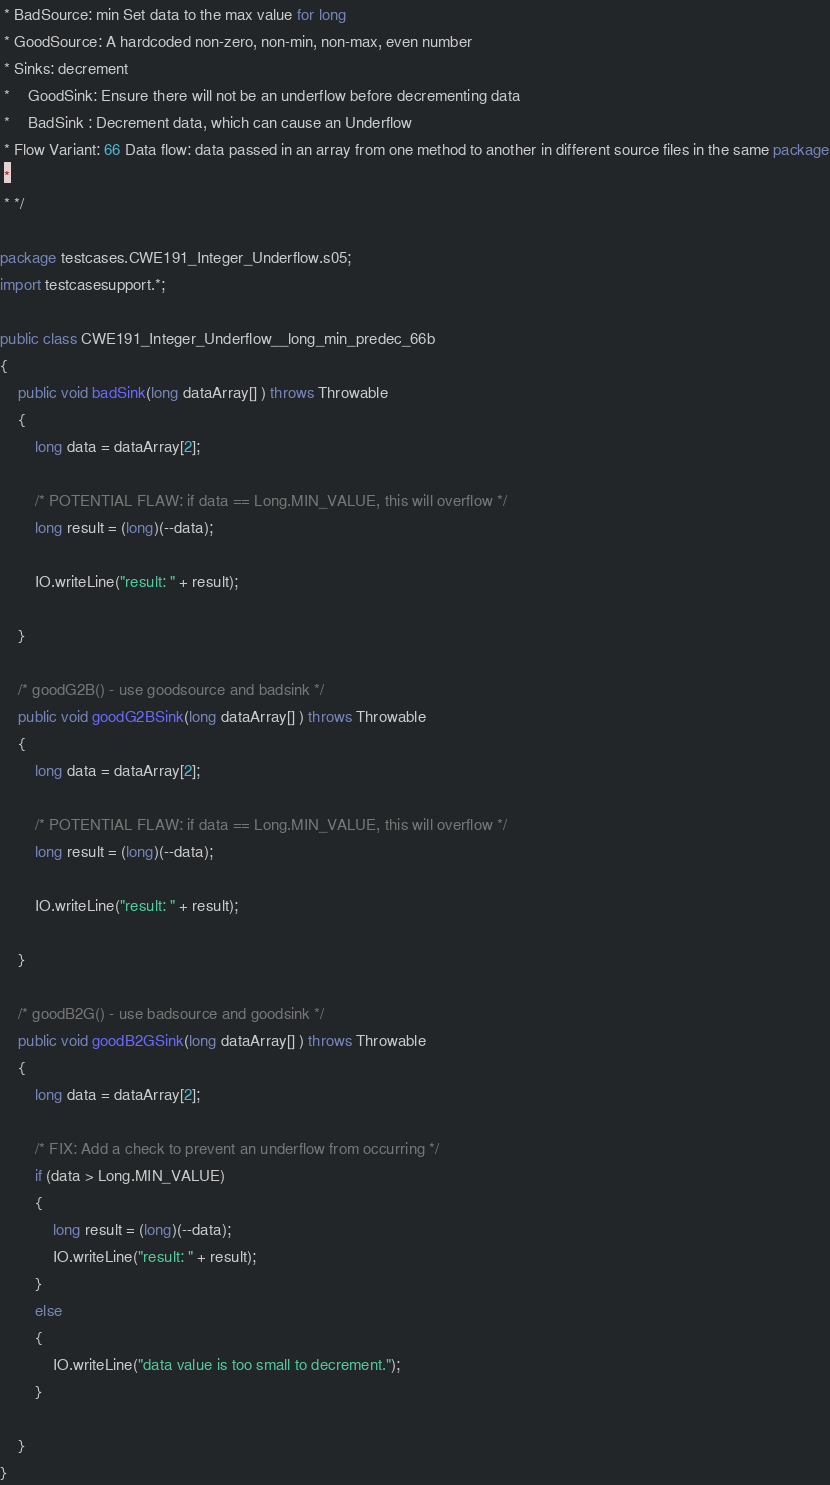<code> <loc_0><loc_0><loc_500><loc_500><_Java_> * BadSource: min Set data to the max value for long
 * GoodSource: A hardcoded non-zero, non-min, non-max, even number
 * Sinks: decrement
 *    GoodSink: Ensure there will not be an underflow before decrementing data
 *    BadSink : Decrement data, which can cause an Underflow
 * Flow Variant: 66 Data flow: data passed in an array from one method to another in different source files in the same package
 *
 * */

package testcases.CWE191_Integer_Underflow.s05;
import testcasesupport.*;

public class CWE191_Integer_Underflow__long_min_predec_66b
{
    public void badSink(long dataArray[] ) throws Throwable
    {
        long data = dataArray[2];

        /* POTENTIAL FLAW: if data == Long.MIN_VALUE, this will overflow */
        long result = (long)(--data);

        IO.writeLine("result: " + result);

    }

    /* goodG2B() - use goodsource and badsink */
    public void goodG2BSink(long dataArray[] ) throws Throwable
    {
        long data = dataArray[2];

        /* POTENTIAL FLAW: if data == Long.MIN_VALUE, this will overflow */
        long result = (long)(--data);

        IO.writeLine("result: " + result);

    }

    /* goodB2G() - use badsource and goodsink */
    public void goodB2GSink(long dataArray[] ) throws Throwable
    {
        long data = dataArray[2];

        /* FIX: Add a check to prevent an underflow from occurring */
        if (data > Long.MIN_VALUE)
        {
            long result = (long)(--data);
            IO.writeLine("result: " + result);
        }
        else
        {
            IO.writeLine("data value is too small to decrement.");
        }

    }
}
</code> 